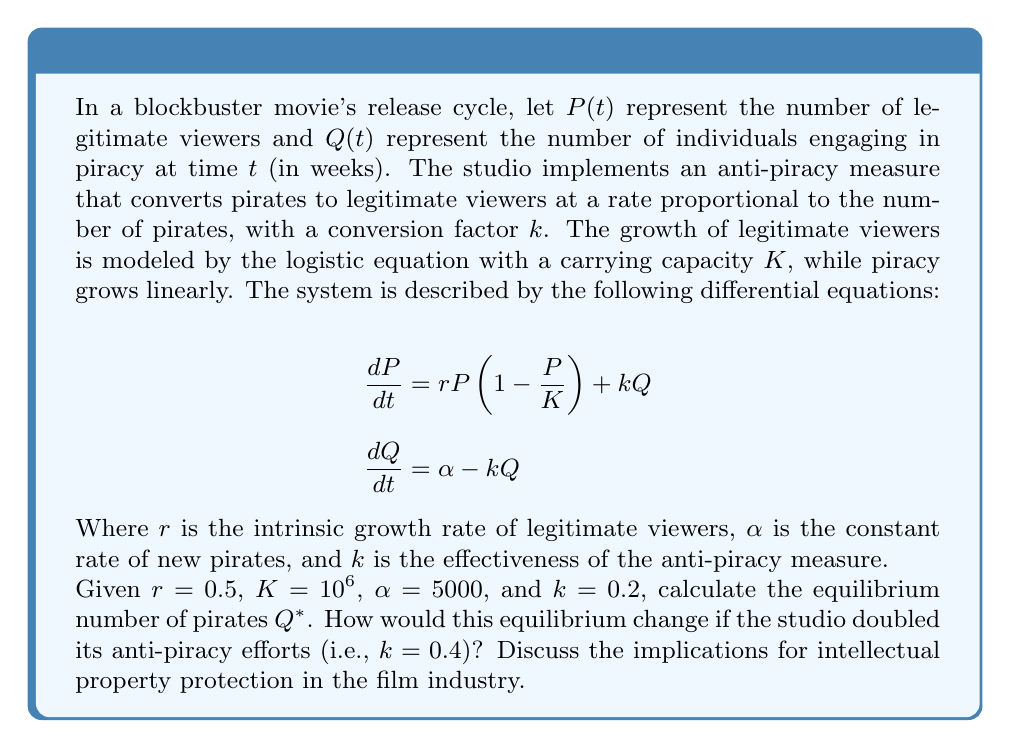Provide a solution to this math problem. To solve this problem, we'll follow these steps:

1) First, we need to find the equilibrium point. At equilibrium, both $\frac{dP}{dt}$ and $\frac{dQ}{dt}$ should be zero.

2) Let's focus on the piracy equation:

   $$\frac{dQ}{dt} = \alpha - kQ = 0$$

3) Solving for $Q$ at equilibrium ($Q^*$):

   $$\alpha - kQ^* = 0$$
   $$kQ^* = \alpha$$
   $$Q^* = \frac{\alpha}{k}$$

4) Now, let's plug in the given values:

   $$Q^* = \frac{5000}{0.2} = 25,000$$

5) To see how this changes when $k$ is doubled to 0.4:

   $$Q^* = \frac{5000}{0.4} = 12,500$$

6) The implications for intellectual property protection are significant:

   - When $k = 0.2$, the equilibrium number of pirates is 25,000.
   - When $k = 0.4$, the equilibrium number of pirates is reduced to 12,500.

   This demonstrates that doubling the effectiveness of anti-piracy measures (represented by $k$) halves the equilibrium number of pirates. 

   From an intellectual property law perspective, this model suggests that investing in more effective anti-piracy measures can significantly reduce piracy. However, it's important to note that there are diminishing returns: doubling the effectiveness doesn't eliminate piracy entirely, it only reduces it by half.

   The model also implies that as long as there's a constant influx of new pirates ($\alpha$), piracy can never be completely eliminated, only minimized. This reflects the real-world challenges of protecting intellectual property in the digital age.
Answer: $Q^* = 25,000$ pirates when $k = 0.2$; $Q^* = 12,500$ pirates when $k = 0.4$. Doubling anti-piracy effectiveness halves equilibrium piracy, demonstrating significant but diminishing returns on anti-piracy investments. 